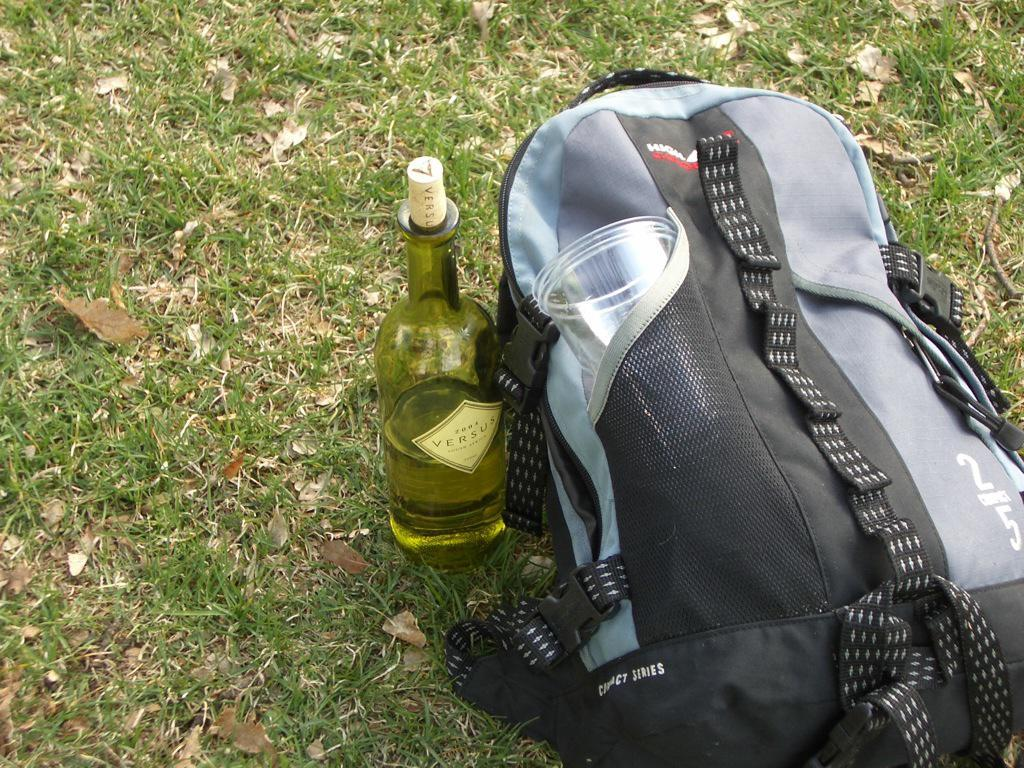What is on the floor in the image? There is a bag on the floor in the image. What is located near the bag? There is a bottle beside the bag in the image. What type of natural scenery can be seen in the image? Trees are visible in the image. What type of building can be seen in the image? There is no building present in the image; it features a bag, a bottle, and trees. What is the neck of the person in the image doing? There is no person present in the image, so it is not possible to determine what their neck is doing. 